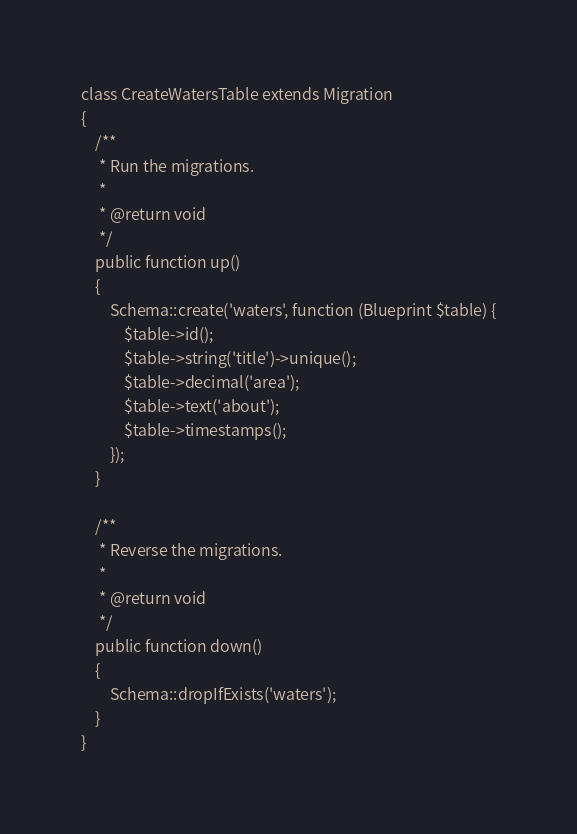Convert code to text. <code><loc_0><loc_0><loc_500><loc_500><_PHP_>class CreateWatersTable extends Migration
{
    /**
     * Run the migrations.
     *
     * @return void
     */
    public function up()
    {
        Schema::create('waters', function (Blueprint $table) {
            $table->id();
            $table->string('title')->unique();
            $table->decimal('area');
            $table->text('about');
            $table->timestamps();
        });
    }

    /**
     * Reverse the migrations.
     *
     * @return void
     */
    public function down()
    {
        Schema::dropIfExists('waters');
    }
}
</code> 